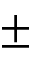Convert formula to latex. <formula><loc_0><loc_0><loc_500><loc_500>\pm</formula> 